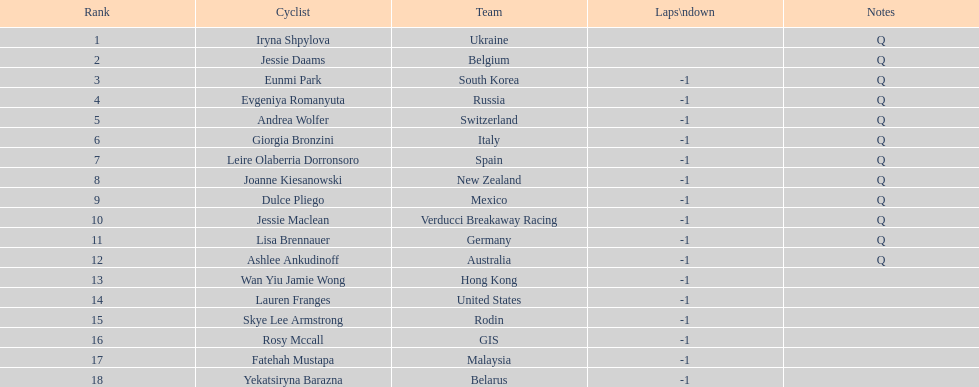Parse the full table. {'header': ['Rank', 'Cyclist', 'Team', 'Laps\\ndown', 'Notes'], 'rows': [['1', 'Iryna Shpylova', 'Ukraine', '', 'Q'], ['2', 'Jessie Daams', 'Belgium', '', 'Q'], ['3', 'Eunmi Park', 'South Korea', '-1', 'Q'], ['4', 'Evgeniya Romanyuta', 'Russia', '-1', 'Q'], ['5', 'Andrea Wolfer', 'Switzerland', '-1', 'Q'], ['6', 'Giorgia Bronzini', 'Italy', '-1', 'Q'], ['7', 'Leire Olaberria Dorronsoro', 'Spain', '-1', 'Q'], ['8', 'Joanne Kiesanowski', 'New Zealand', '-1', 'Q'], ['9', 'Dulce Pliego', 'Mexico', '-1', 'Q'], ['10', 'Jessie Maclean', 'Verducci Breakaway Racing', '-1', 'Q'], ['11', 'Lisa Brennauer', 'Germany', '-1', 'Q'], ['12', 'Ashlee Ankudinoff', 'Australia', '-1', 'Q'], ['13', 'Wan Yiu Jamie Wong', 'Hong Kong', '-1', ''], ['14', 'Lauren Franges', 'United States', '-1', ''], ['15', 'Skye Lee Armstrong', 'Rodin', '-1', ''], ['16', 'Rosy Mccall', 'GIS', '-1', ''], ['17', 'Fatehah Mustapa', 'Malaysia', '-1', ''], ['18', 'Yekatsiryna Barazna', 'Belarus', '-1', '']]} Which competitor was the first to end the race one lap behind? Eunmi Park. 